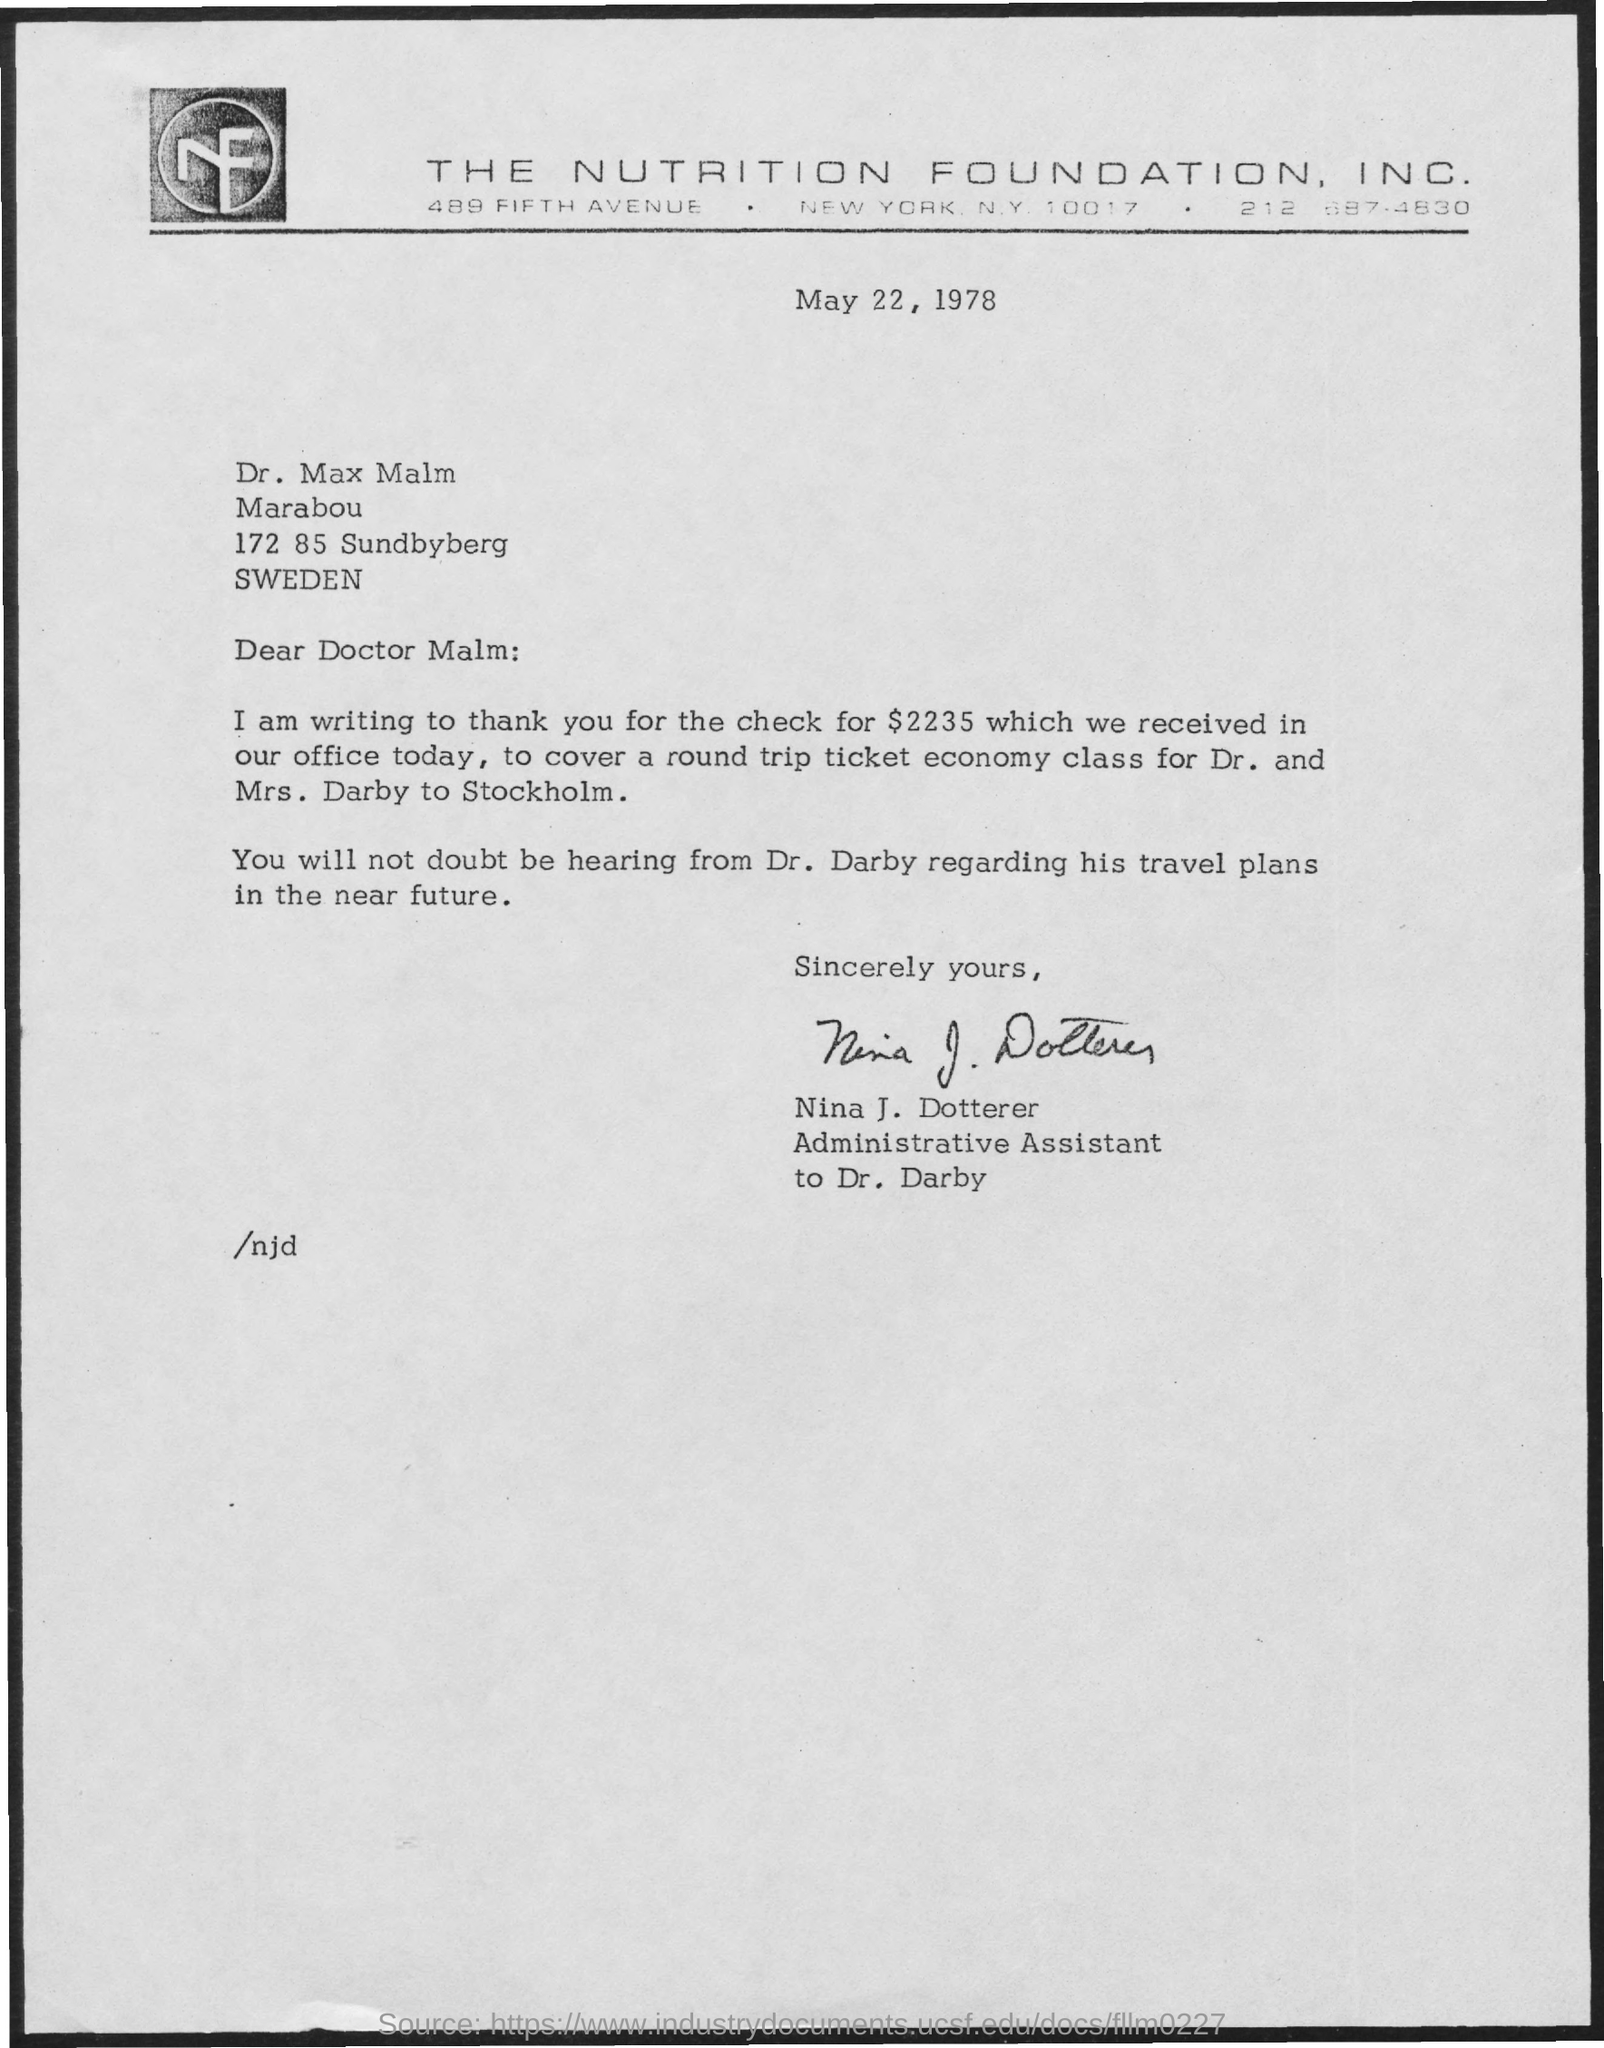Which company is mentioned in the letter head?
Give a very brief answer. THE NUTRITION FOUNDATION, INC. Who has signed this letter?
Provide a short and direct response. Nina J. Dotterer. What is the date mentioned in this letter?
Your answer should be very brief. May 22, 1978. 